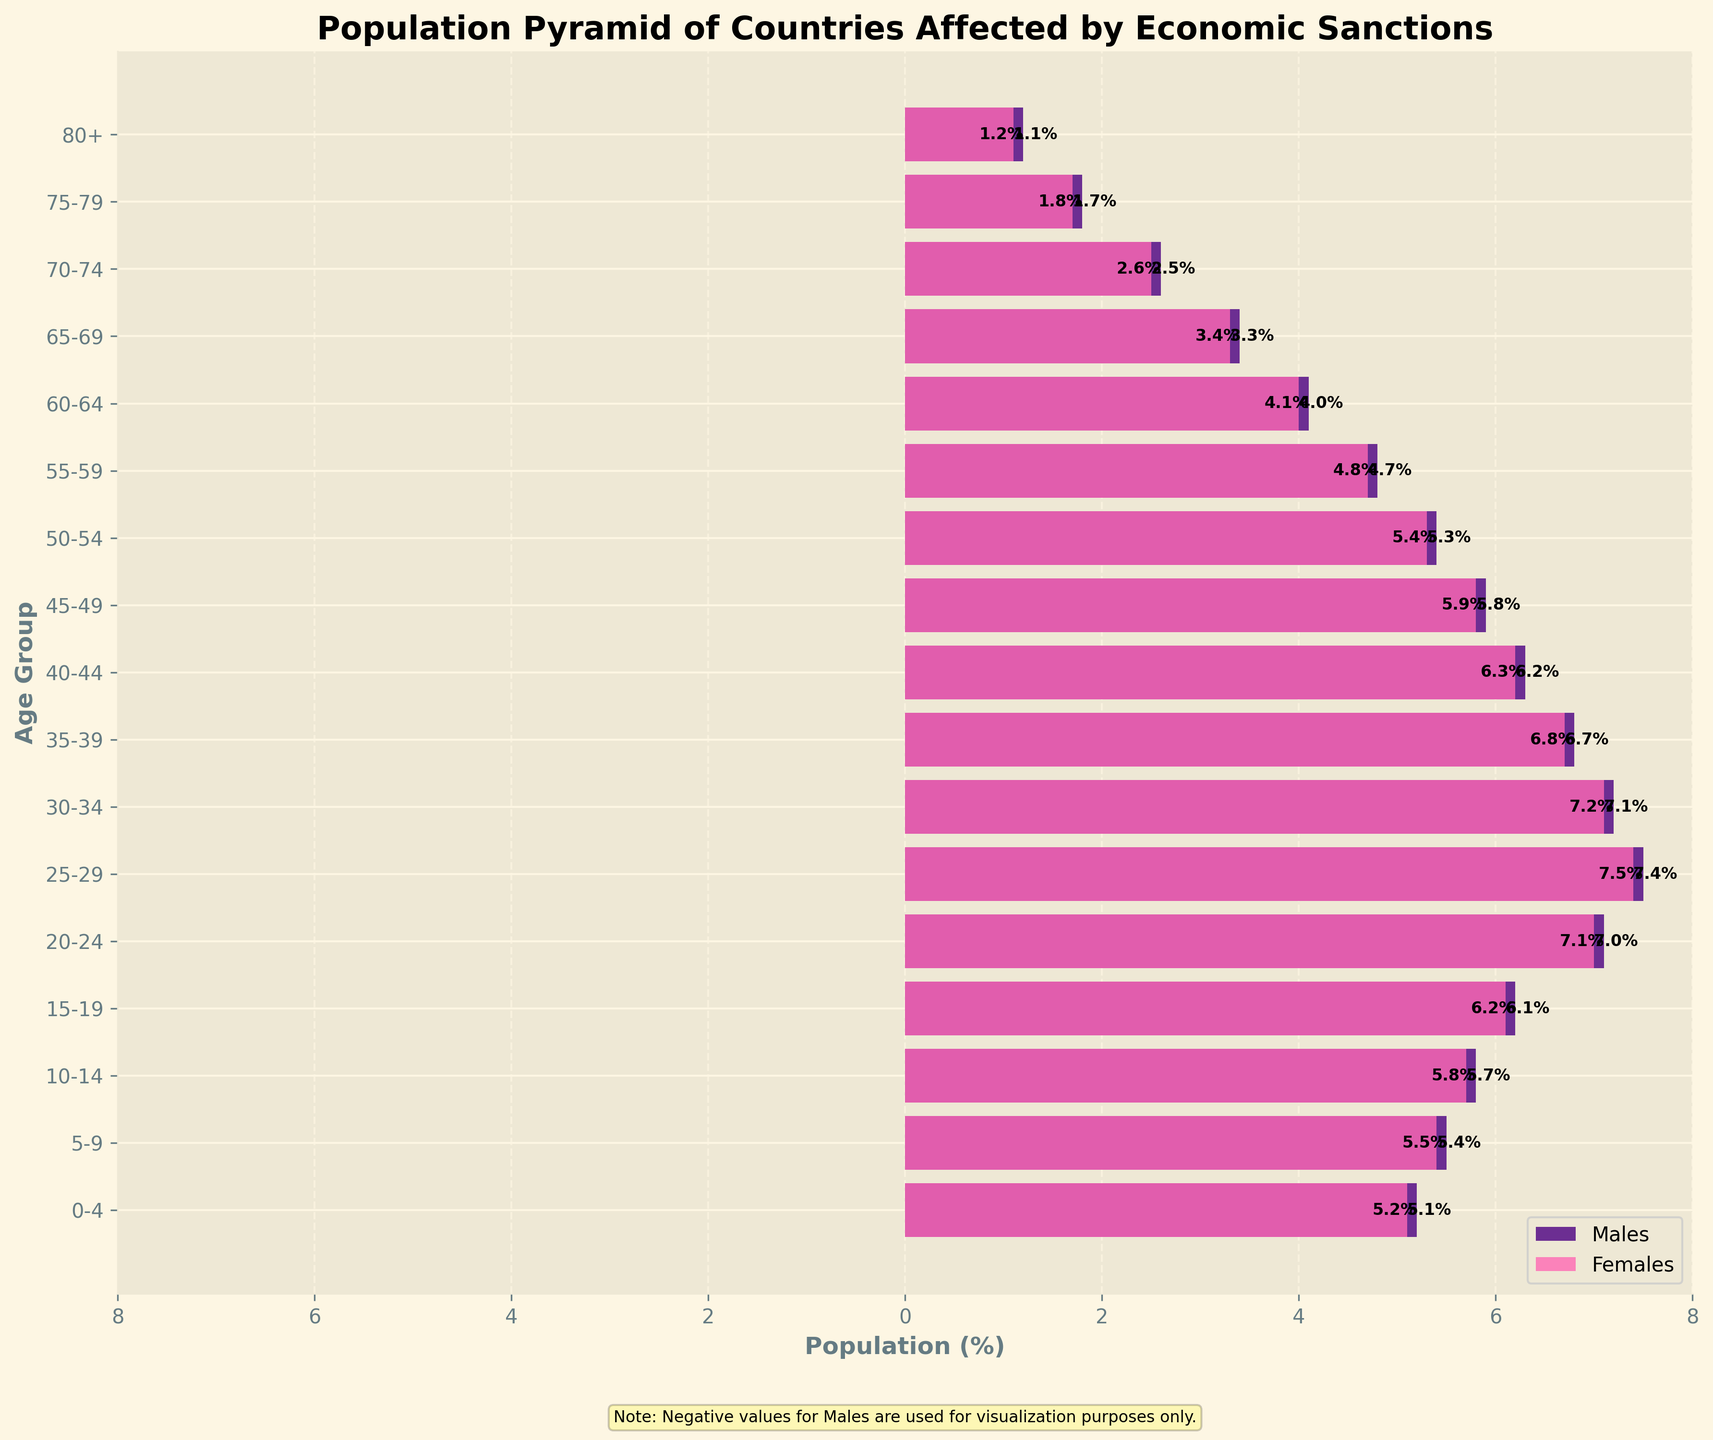What's the title of the figure? The title of the figure is displayed at the top and usually summarizes the main message or content of the visualization.
Answer: Population Pyramid of Countries Affected by Economic Sanctions Which gender has a higher population percentage in the 20-24 age group? Comparing the bars for males and females in the 20-24 age group, the female bar is slightly shorter than the male bar, indicating a higher percentage for males.
Answer: Males What is the percentage of males in the 60-64 age group? Locate the bar for males in the 60-64 age group and read the value. The bar for males in this age group extends to 4.1%.
Answer: 4.1% What is the difference in population percentage between males and females in the 15-19 age group? Males have a percentage of 6.2%, and females have a percentage of 6.1%. Subtracting these values gives 6.2% - 6.1% = 0.1%.
Answer: 0.1% How does the population percentage of females in the 25-29 age group compare to that in the 70-74 age group? The bar for females in the 25-29 age group extends to 7.4%, while the bar for the 70-74 age group extends to 2.5%. 7.4% is significantly higher than 2.5%.
Answer: The percentage is higher for the 25-29 age group What trends can you observe in the population percentages across the age groups from 0 to 80+ among males and females? For both genders, the population percentage decreases uniformly as age increases, starting at high values for younger age groups and tapering off for older age groups.
Answer: Decreasing trend What is the average population percentage for males across all age groups? Summing the male percentages: 5.2 + 5.5 + 5.8 + 6.2 + 7.1 + 7.5 + 7.2 + 6.8 + 6.3 + 5.9 + 5.4 + 4.8 + 4.1 + 3.4 + 2.6 + 1.8 + 1.2 = 86.8. There are 17 age groups, so the average is 86.8 / 17 ≈ 5.1%.
Answer: 5.1% In which age group is the gender population percentage difference largest? The population percentage differences in various age groups need to be evaluated. The 25-29 group has males at 7.5% and females at 7.4%, with a difference of 0.1%. After evaluating all, it appears that the 80+ group has males at 1.2% and females at 1.1%, with a difference of 0.1%.
Answer: 25-29 or 80+ Why does the x-axis have negative values for males? The negative values are used for visualization purposes to distinguish between males and females on the population pyramid more clearly. This method is common for population pyramids to allow straightforward comparison of gender distributions.
Answer: For visualization How might the potential workforce be impacted by economic sanctions based on this population pyramid? The age groups 15-64 are crucial for the workforce. A larger population in these age groups indicates a potentially robust workforce, but sanctions could hinder economic performance, job access, and growth within this segment. Understanding these implications requires a deeper analysis.
Answer: Potentially hindered workforce due to sanctions 